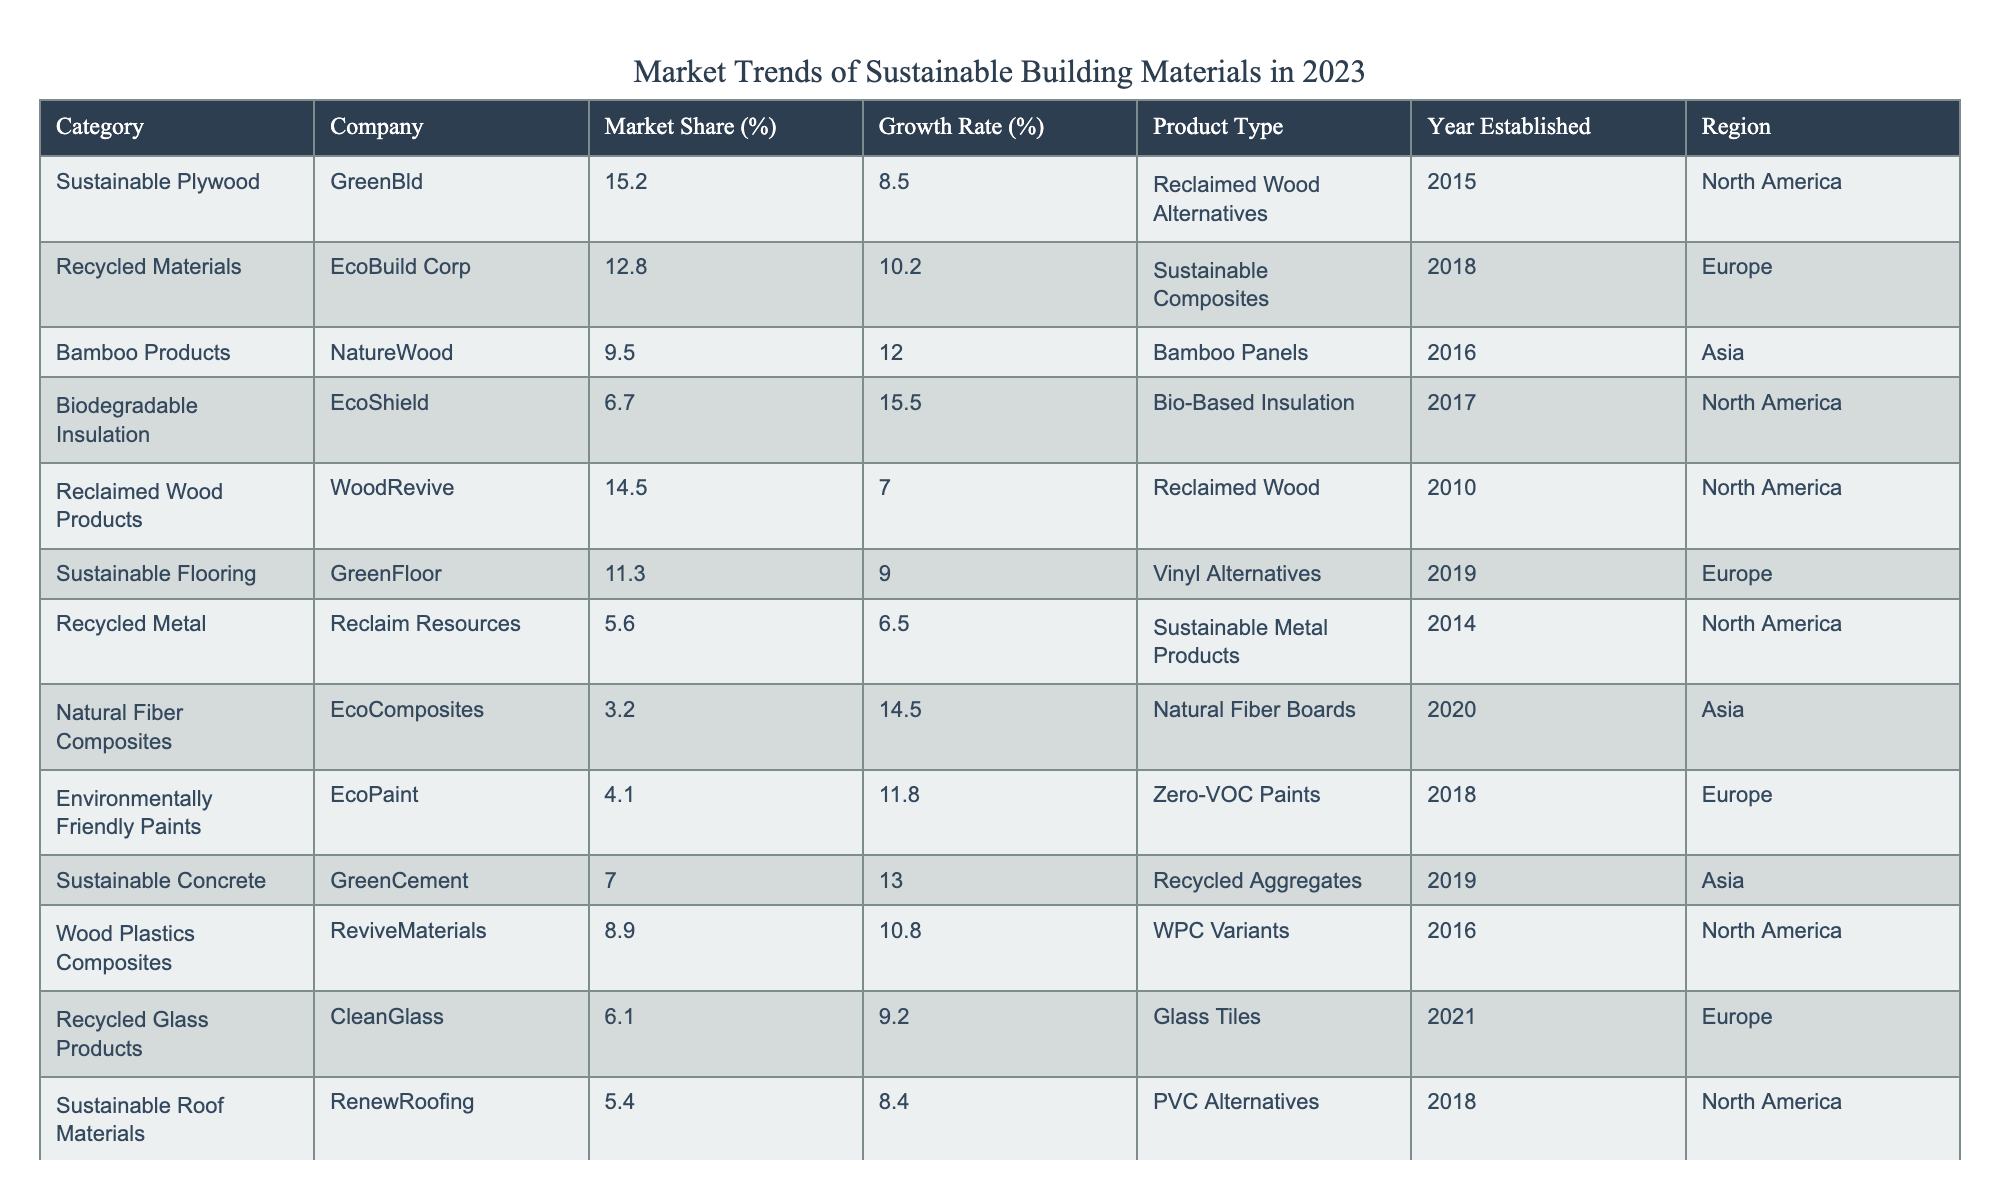What's the company with the highest market share? Looking through the Market Share column, GreenBld has the highest market share at 15.2%.
Answer: GreenBld Which product type has the highest growth rate? The highest growth rate can be found in the Growth Rate column, where HempBuild has a growth rate of 17.0%.
Answer: Hemp Materials What is the average market share of companies from North America? The market shares for North American companies are 15.2, 14.5, 6.7, 5.6, and 5.4. Summing these gives 47.4, and there are 5 companies, so the average is 47.4/5 = 9.48%.
Answer: 9.48% Is EcoBuild Corp the only European company with a growth rate above 10%? Checking the Growth Rate column for European companies, EcoBuild Corp has 10.2%, GreenFloor has 9.0%, and EcoPaint has 11.8%. Hence, EcoBuild Corp is not the only one, as EcoPaint also exceeds 10%.
Answer: No What is the total growth rate of all companies in Asia? The growth rates for companies from Asia are 12.0, 14.5, and 13.0. Summing these gives 12.0 + 14.5 + 13.0 = 39.5%.
Answer: 39.5% Which region has the most companies listed in the table? Counting the entries for each region, North America has 5 entries, Europe has 4, and Asia has 3, indicating that North America has the most companies listed.
Answer: North America How many companies have market shares below 5%? Reviewing the Market Share column, there are no companies with a market share below 5%, as the lowest is 2.3%.
Answer: 0 What is the difference between the highest and lowest growth rates among all companies? The highest growth rate is 17.0% (HempBuild) and the lowest is 6.5% (Reclaim Resources). The difference is 17.0 - 6.5 = 10.5%.
Answer: 10.5% Which product type is produced by the company with the oldest establishment year? The company with the oldest establishment year is WoodRevive, established in 2010, and their product type is Reclaimed Wood.
Answer: Reclaimed Wood What percentage of the total market share is contributed by companies that produce sustainable plywood products? Only GreenBld falls under sustainable plywood, contributing 15.2%. Thus, this is the percentage contributed by that category.
Answer: 15.2% 